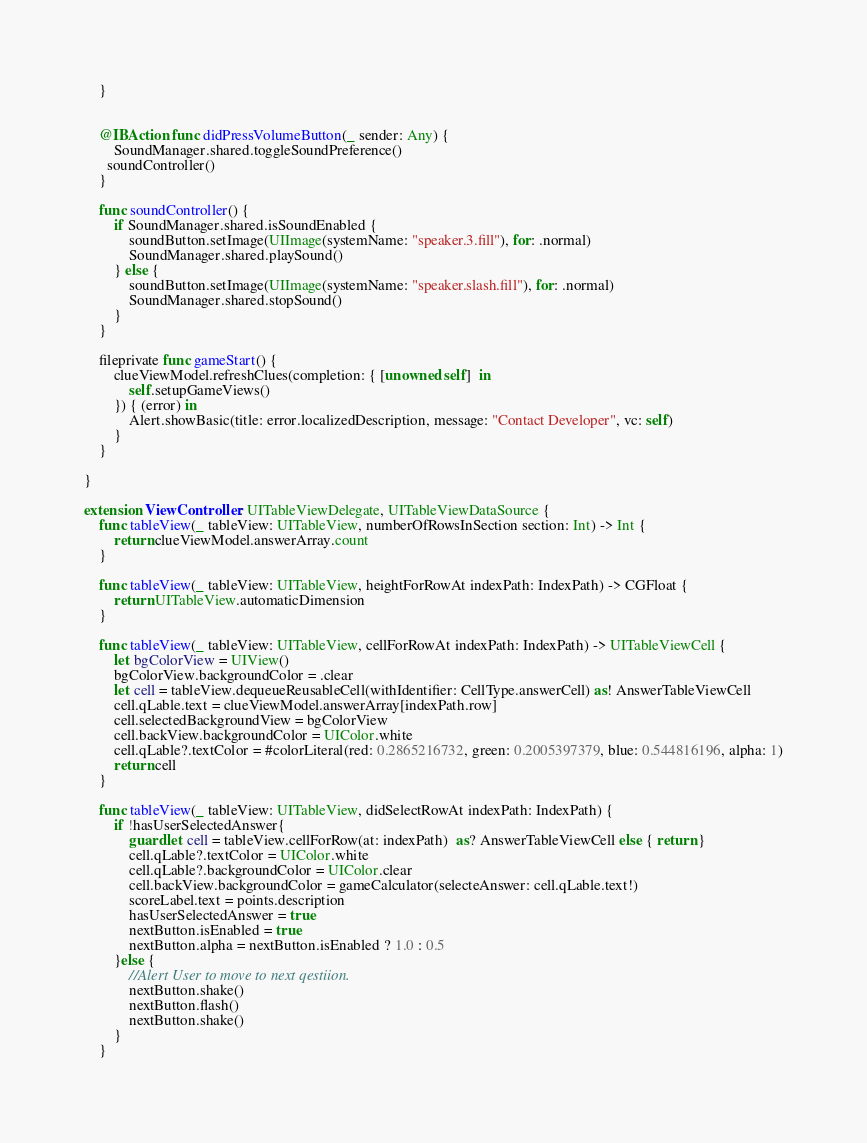<code> <loc_0><loc_0><loc_500><loc_500><_Swift_>    }


    @IBAction func didPressVolumeButton(_ sender: Any) {
        SoundManager.shared.toggleSoundPreference()
      soundController()
    }

    func soundController() {
        if SoundManager.shared.isSoundEnabled {
            soundButton.setImage(UIImage(systemName: "speaker.3.fill"), for: .normal)
            SoundManager.shared.playSound()
        } else {
            soundButton.setImage(UIImage(systemName: "speaker.slash.fill"), for: .normal)
            SoundManager.shared.stopSound()
        }
    }

    fileprivate func gameStart() {
        clueViewModel.refreshClues(completion: { [unowned self]  in 
            self.setupGameViews()
        }) { (error) in
            Alert.showBasic(title: error.localizedDescription, message: "Contact Developer", vc: self)
        }
    }

}

extension ViewController: UITableViewDelegate, UITableViewDataSource {
    func tableView(_ tableView: UITableView, numberOfRowsInSection section: Int) -> Int {
        return clueViewModel.answerArray.count
    }

    func tableView(_ tableView: UITableView, heightForRowAt indexPath: IndexPath) -> CGFloat {
        return UITableView.automaticDimension
    }

    func tableView(_ tableView: UITableView, cellForRowAt indexPath: IndexPath) -> UITableViewCell {
        let bgColorView = UIView()
        bgColorView.backgroundColor = .clear
        let cell = tableView.dequeueReusableCell(withIdentifier: CellType.answerCell) as! AnswerTableViewCell
        cell.qLable.text = clueViewModel.answerArray[indexPath.row]
        cell.selectedBackgroundView = bgColorView
        cell.backView.backgroundColor = UIColor.white
        cell.qLable?.textColor = #colorLiteral(red: 0.2865216732, green: 0.2005397379, blue: 0.544816196, alpha: 1)
        return cell
    }

    func tableView(_ tableView: UITableView, didSelectRowAt indexPath: IndexPath) {
        if !hasUserSelectedAnswer{
            guard let cell = tableView.cellForRow(at: indexPath)  as? AnswerTableViewCell else { return }
            cell.qLable?.textColor = UIColor.white
            cell.qLable?.backgroundColor = UIColor.clear
            cell.backView.backgroundColor = gameCalculator(selecteAnswer: cell.qLable.text!)
            scoreLabel.text = points.description
            hasUserSelectedAnswer = true
            nextButton.isEnabled = true
            nextButton.alpha = nextButton.isEnabled ? 1.0 : 0.5
        }else {
            //Alert User to move to next qestiion.
            nextButton.shake()
            nextButton.flash()
            nextButton.shake()
        }
    }
</code> 